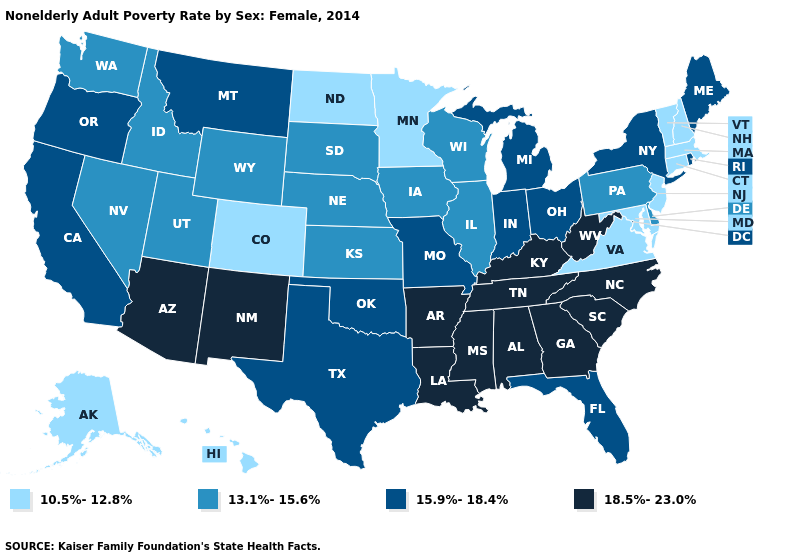Name the states that have a value in the range 15.9%-18.4%?
Write a very short answer. California, Florida, Indiana, Maine, Michigan, Missouri, Montana, New York, Ohio, Oklahoma, Oregon, Rhode Island, Texas. Which states have the lowest value in the South?
Be succinct. Maryland, Virginia. Among the states that border Illinois , which have the lowest value?
Quick response, please. Iowa, Wisconsin. Among the states that border Florida , which have the highest value?
Keep it brief. Alabama, Georgia. Does North Carolina have a higher value than Alabama?
Be succinct. No. Which states hav the highest value in the South?
Answer briefly. Alabama, Arkansas, Georgia, Kentucky, Louisiana, Mississippi, North Carolina, South Carolina, Tennessee, West Virginia. Is the legend a continuous bar?
Be succinct. No. What is the value of Idaho?
Keep it brief. 13.1%-15.6%. Name the states that have a value in the range 15.9%-18.4%?
Write a very short answer. California, Florida, Indiana, Maine, Michigan, Missouri, Montana, New York, Ohio, Oklahoma, Oregon, Rhode Island, Texas. What is the value of Wisconsin?
Write a very short answer. 13.1%-15.6%. What is the value of Connecticut?
Be succinct. 10.5%-12.8%. Which states have the lowest value in the USA?
Short answer required. Alaska, Colorado, Connecticut, Hawaii, Maryland, Massachusetts, Minnesota, New Hampshire, New Jersey, North Dakota, Vermont, Virginia. Name the states that have a value in the range 10.5%-12.8%?
Short answer required. Alaska, Colorado, Connecticut, Hawaii, Maryland, Massachusetts, Minnesota, New Hampshire, New Jersey, North Dakota, Vermont, Virginia. Does Maine have the highest value in the Northeast?
Write a very short answer. Yes. Name the states that have a value in the range 15.9%-18.4%?
Give a very brief answer. California, Florida, Indiana, Maine, Michigan, Missouri, Montana, New York, Ohio, Oklahoma, Oregon, Rhode Island, Texas. 